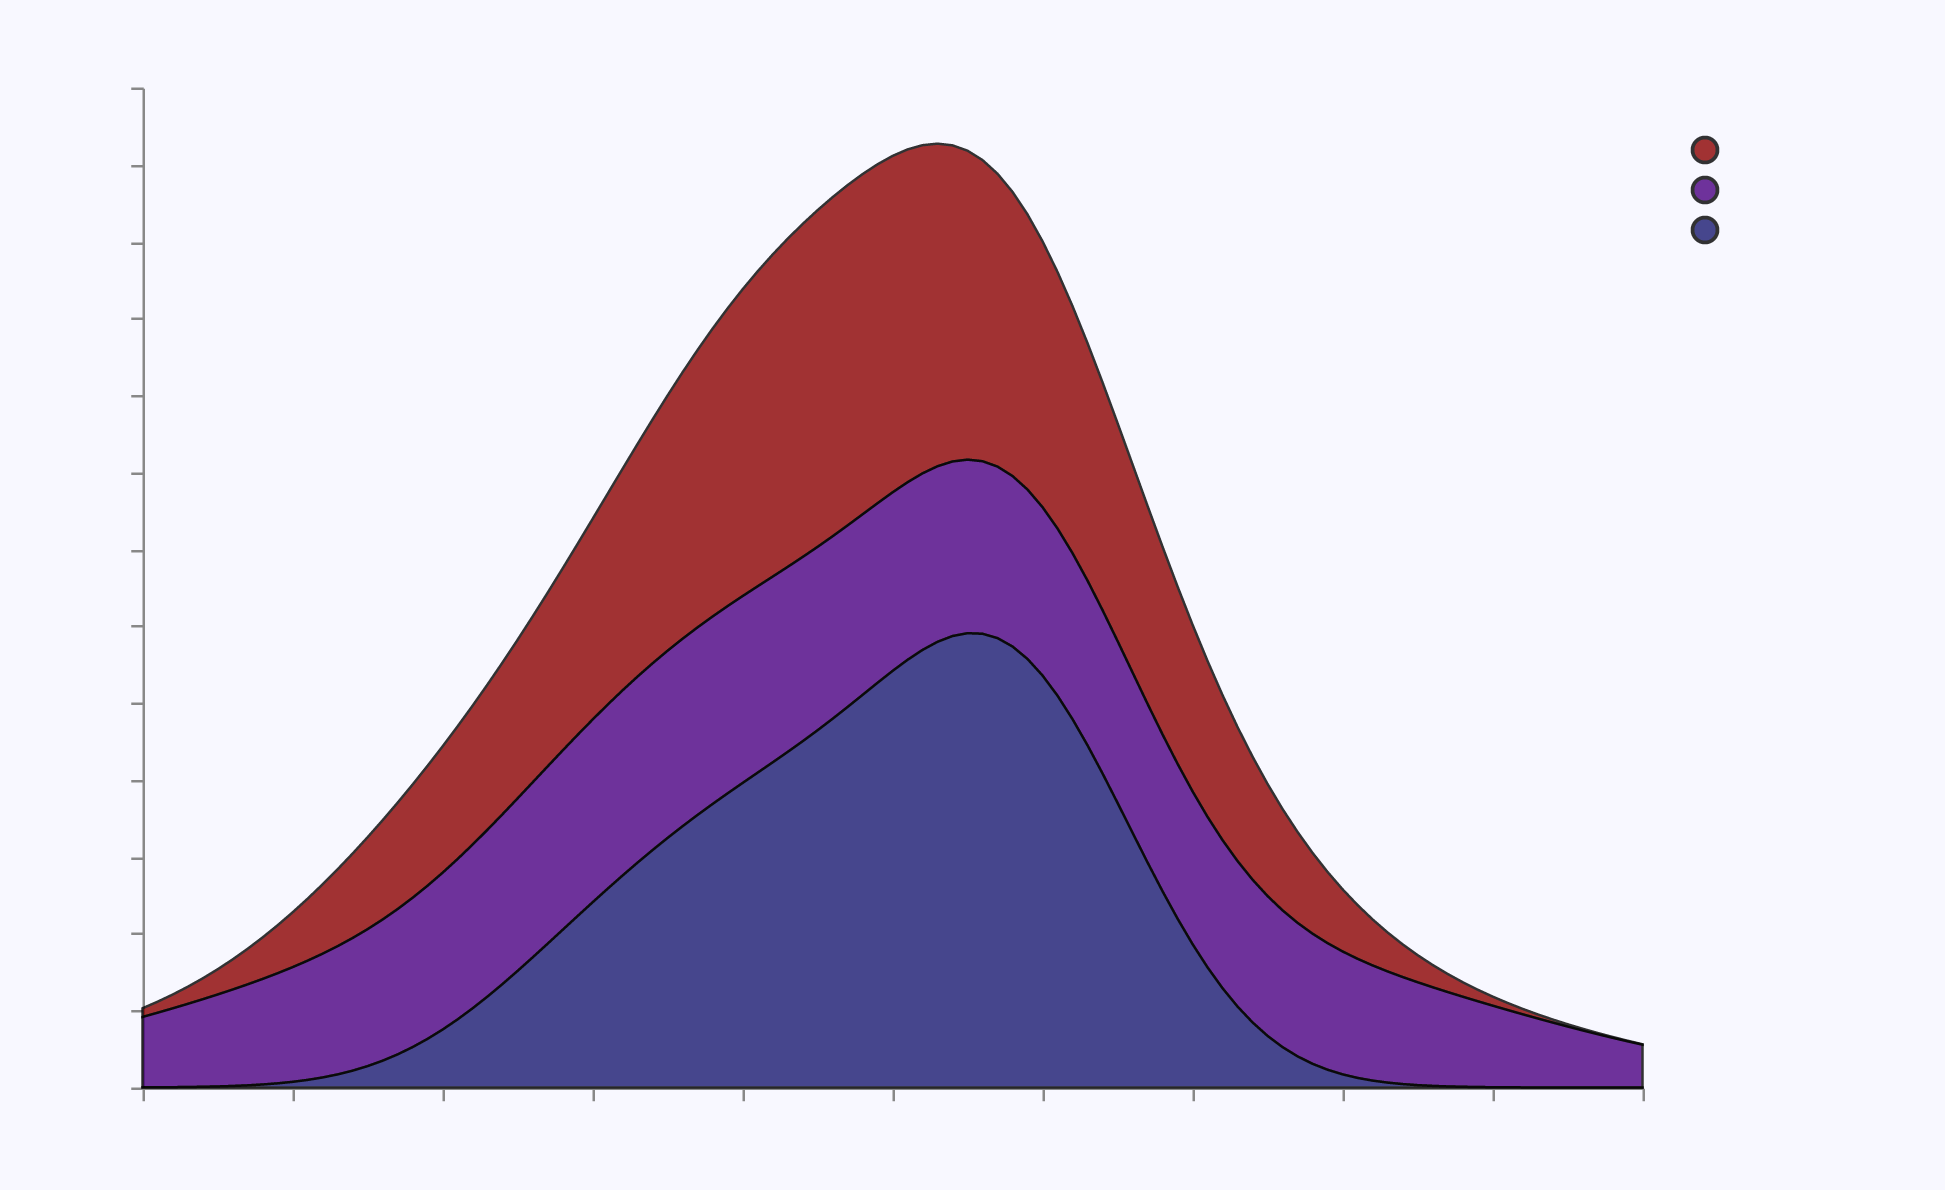What is the title of the figure? The title of the figure is displayed at the top of the chart. It provides a summary of what the plot represents.
Answer: Emotional Tone Distribution in Gothic Literature What are the colors used to represent the different emotions? The colors for each emotion can be identified from the legend on the right side of the chart.
Answer: Fear is dark red, Melancholy is dark indigo, and Suspense is midnight blue Which emotion has the highest density at Tone Score of 0.85? By finding Tone Score 0.85 on the x-axis and looking up to see which density curve is highest, you can determine the answer.
Answer: Fear What emotion has the lowest density peak? By observing the height of the peaks of the density curves for each emotion, you can identify the one with the lowest peak.
Answer: Suspense At what Tone Score do Melancholy and Suspense have approximately equal densities? By examining the figure, you can find the point on the x-axis where the density curves of Melancholy and Suspense intersect.
Answer: Around 0.78 What emotion has the broadest spread of Tone Scores (widest range of densities)? By comparing the width of the density curves along the x-axis, you can see which emotion covers the widest range of Tone Scores.
Answer: Melancholy Which Tone Score shows the highest density for Suspense? By following the Suspense density curve, you can locate the peak value on the x-axis.
Answer: 0.80 Compare the densities of Fear and Melancholy at a Tone Score of 0.75. Which one is higher? By locating Tone Score 0.75 on the x-axis and checking the heights of the Fear and Melancholy density curves, you can determine which one is higher.
Answer: Fear What is the approximate density of Melancholy at a Tone Score of 0.90? By finding Tone Score 0.90 on the x-axis and then identifying how high the Melancholy curve reaches at that score, you can estimate the density.
Answer: Roughly 4.5 Which emotion shows a consistent density over a wide range of Tone Scores? By looking for the emotion whose density curve maintains a relatively steady height across a broad range of Tone Scores, you can determine the answer.
Answer: Suspense 